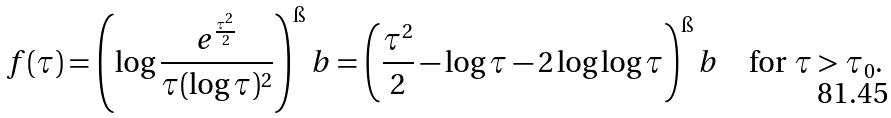Convert formula to latex. <formula><loc_0><loc_0><loc_500><loc_500>f ( \tau ) = \left ( \log \frac { e ^ { \frac { \tau ^ { 2 } } { 2 } } } { \tau ( \log \tau ) ^ { 2 } } \right ) ^ { \i } b = \left ( \frac { \tau ^ { 2 } } { 2 } - \log \tau - 2 \log \log \tau \right ) ^ { \i } b \quad \text {for $\tau>\tau_{0}$.}</formula> 